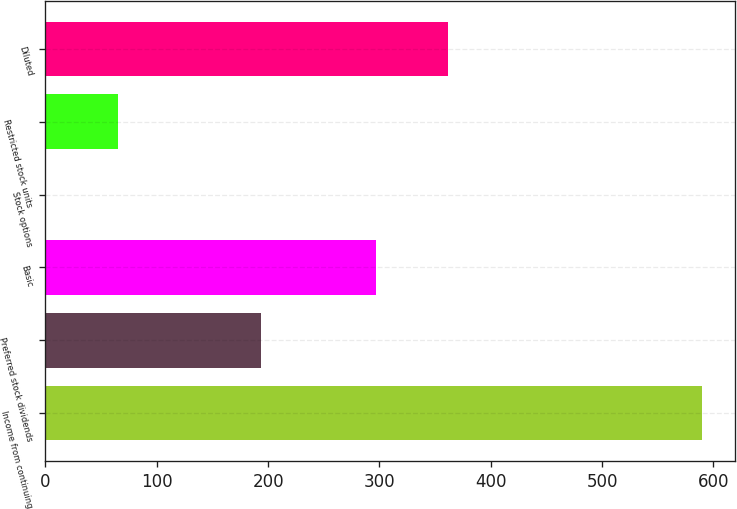Convert chart. <chart><loc_0><loc_0><loc_500><loc_500><bar_chart><fcel>Income from continuing<fcel>Preferred stock dividends<fcel>Basic<fcel>Stock options<fcel>Restricted stock units<fcel>Diluted<nl><fcel>589.7<fcel>193.99<fcel>297.3<fcel>0.4<fcel>64.93<fcel>361.83<nl></chart> 